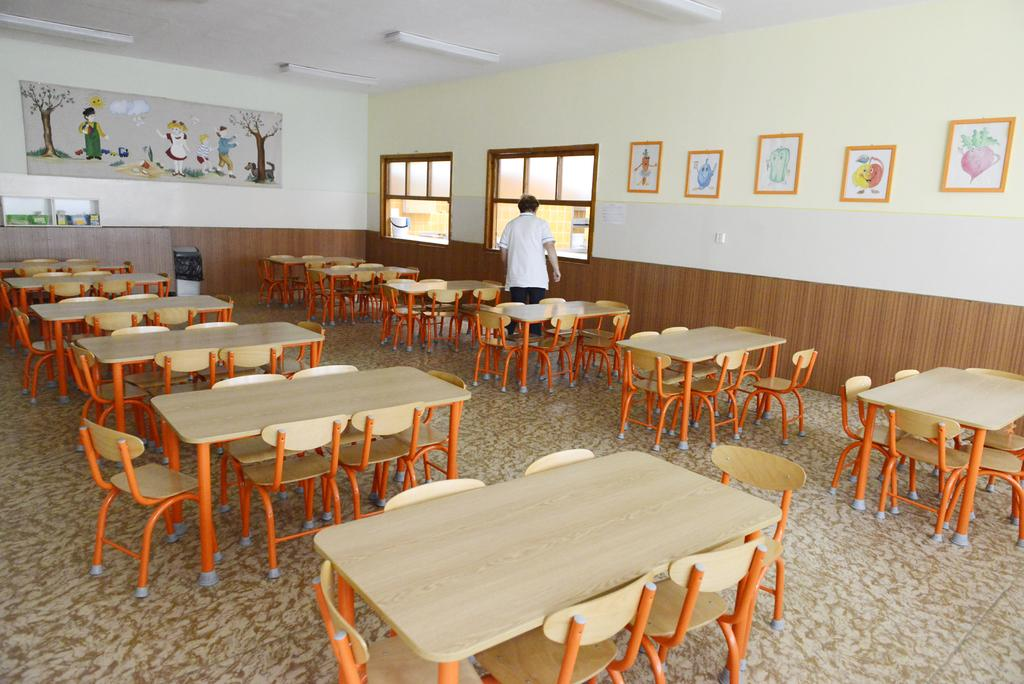What type of furniture is visible in the image? There are chairs and dining tables in the image. Can you describe the setting in which the furniture is located? The furniture is located in a room with windows in the background. What is the man in the image doing? The man is standing in the background of the image. Are there any decorative items on the walls? Yes, photo frames are present on the walls. What type of toothbrush is the man using in the image? There is no toothbrush present in the image; the man is standing in the background. How many birds can be seen flying outside the windows in the image? There are no birds visible in the image; only windows are present in the background. 